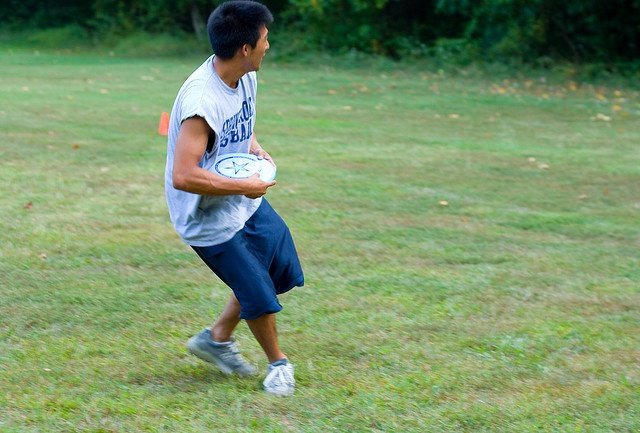Describe the objects in this image and their specific colors. I can see people in black, lavender, navy, and lightblue tones and frisbee in black, white, and lightblue tones in this image. 